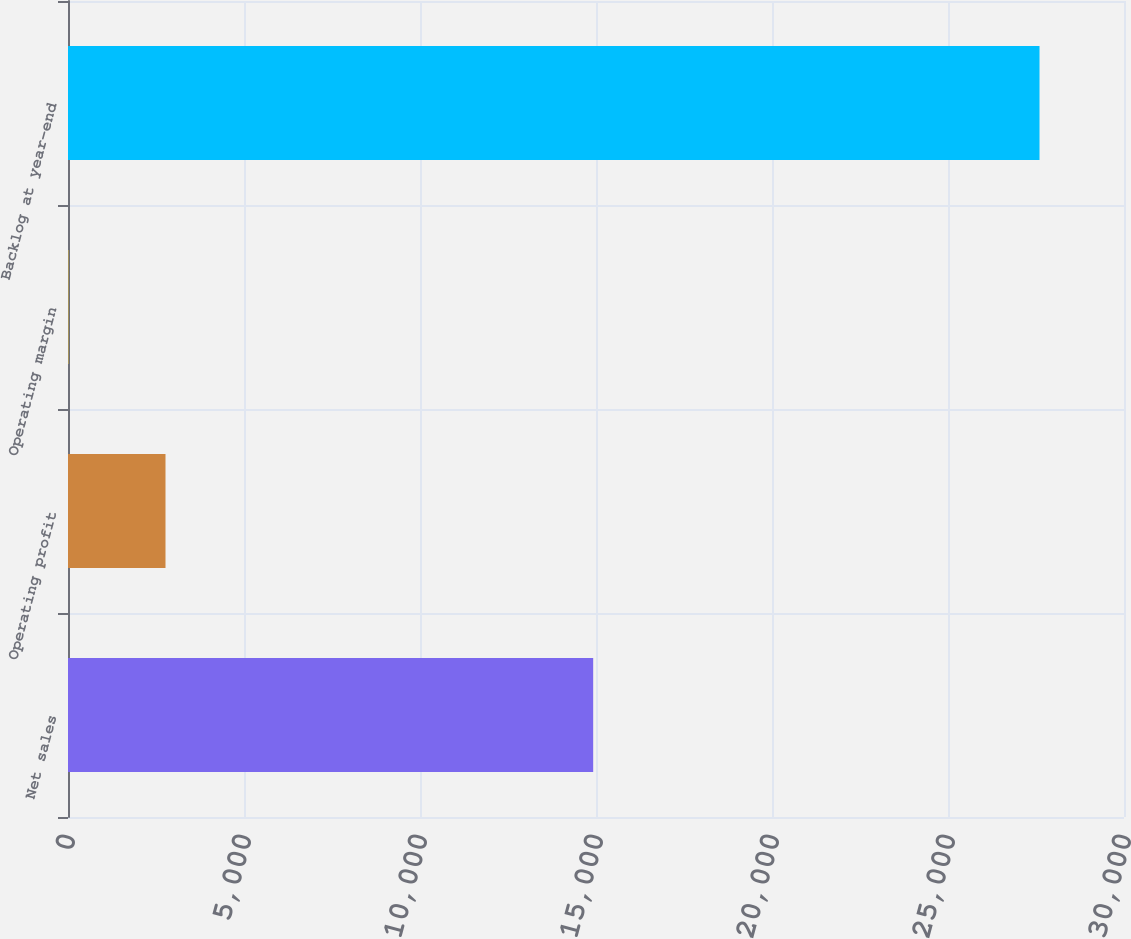Convert chart. <chart><loc_0><loc_0><loc_500><loc_500><bar_chart><fcel>Net sales<fcel>Operating profit<fcel>Operating margin<fcel>Backlog at year-end<nl><fcel>14920<fcel>2769.99<fcel>11.1<fcel>27600<nl></chart> 